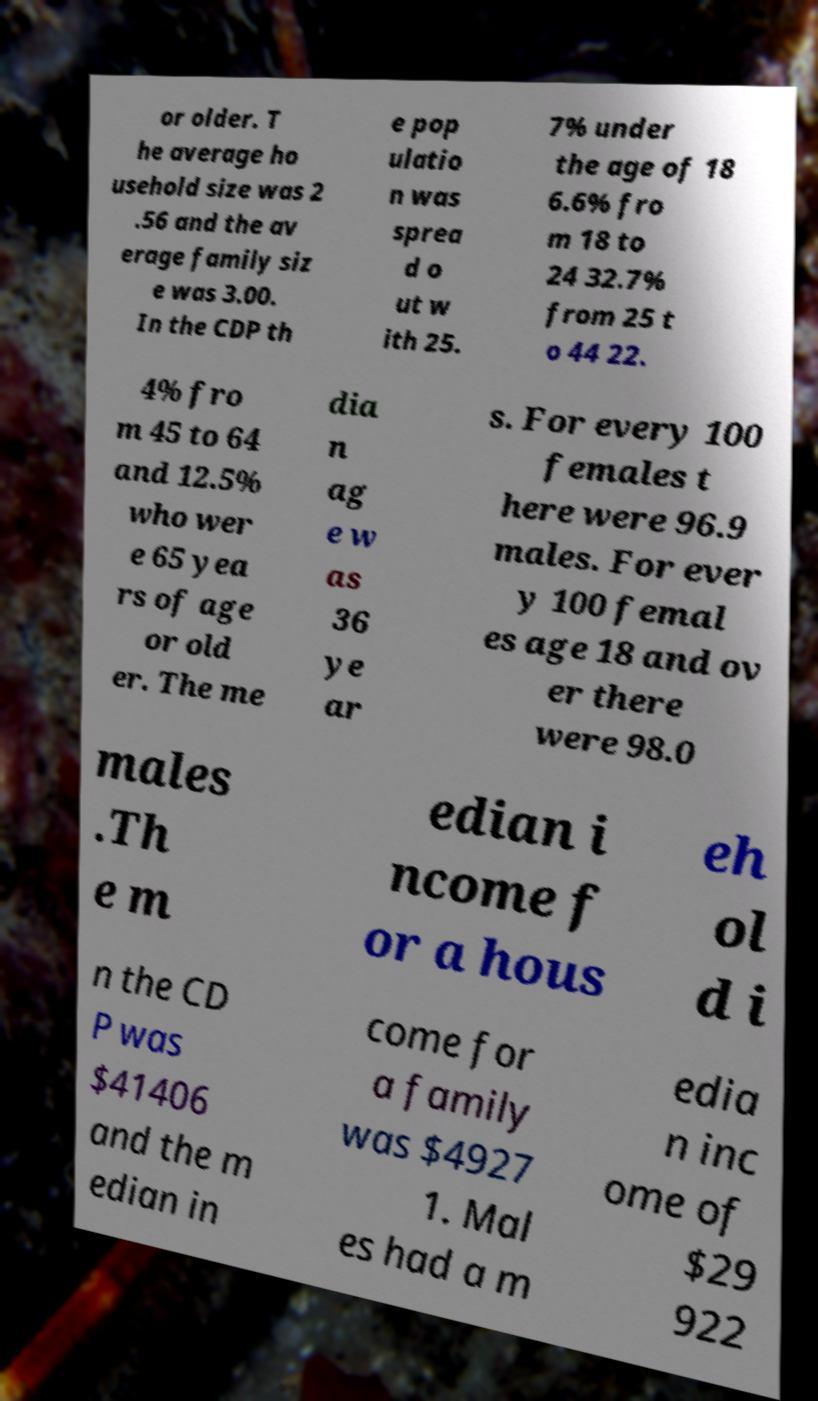Can you read and provide the text displayed in the image?This photo seems to have some interesting text. Can you extract and type it out for me? or older. T he average ho usehold size was 2 .56 and the av erage family siz e was 3.00. In the CDP th e pop ulatio n was sprea d o ut w ith 25. 7% under the age of 18 6.6% fro m 18 to 24 32.7% from 25 t o 44 22. 4% fro m 45 to 64 and 12.5% who wer e 65 yea rs of age or old er. The me dia n ag e w as 36 ye ar s. For every 100 females t here were 96.9 males. For ever y 100 femal es age 18 and ov er there were 98.0 males .Th e m edian i ncome f or a hous eh ol d i n the CD P was $41406 and the m edian in come for a family was $4927 1. Mal es had a m edia n inc ome of $29 922 